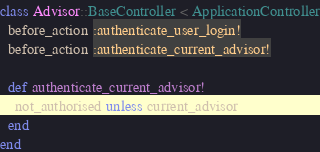<code> <loc_0><loc_0><loc_500><loc_500><_Ruby_>class Advisor::BaseController < ApplicationController
  before_action :authenticate_user_login!
  before_action :authenticate_current_advisor!

  def authenticate_current_advisor!
    not_authorised unless current_advisor
  end
end
</code> 